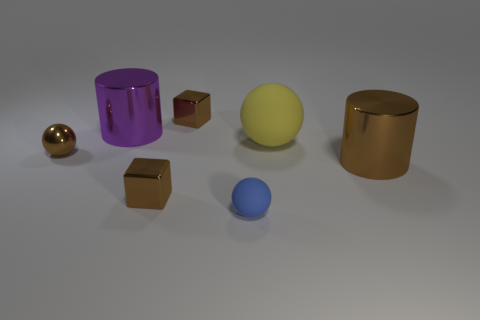What might be the purpose of arranging these objects in this manner? The arrangement of these objects might be intended for a display or to demonstrate various geometric shapes and reflections. It could also serve as a composition exercise in 3D modeling or a graphic design project to practice lighting and shading techniques. Could the colors of the objects have specific significance? Colors in compositions like this could be chosen for aesthetic contrast or to evoke certain emotions or themes. However, without additional context, it's not clear if these specific colors have an intended significance beyond creating a visually pleasing variety. 